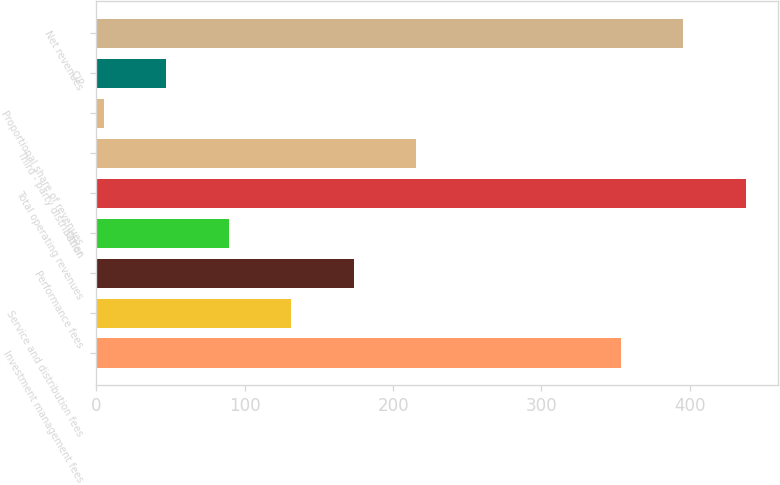<chart> <loc_0><loc_0><loc_500><loc_500><bar_chart><fcel>Investment management fees<fcel>Service and distribution fees<fcel>Performance fees<fcel>Other<fcel>Total operating revenues<fcel>Third - party distribution<fcel>Proportional share of revenues<fcel>CIP<fcel>Net revenues<nl><fcel>353.5<fcel>131.27<fcel>173.36<fcel>89.18<fcel>437.68<fcel>215.45<fcel>5<fcel>47.09<fcel>395.59<nl></chart> 